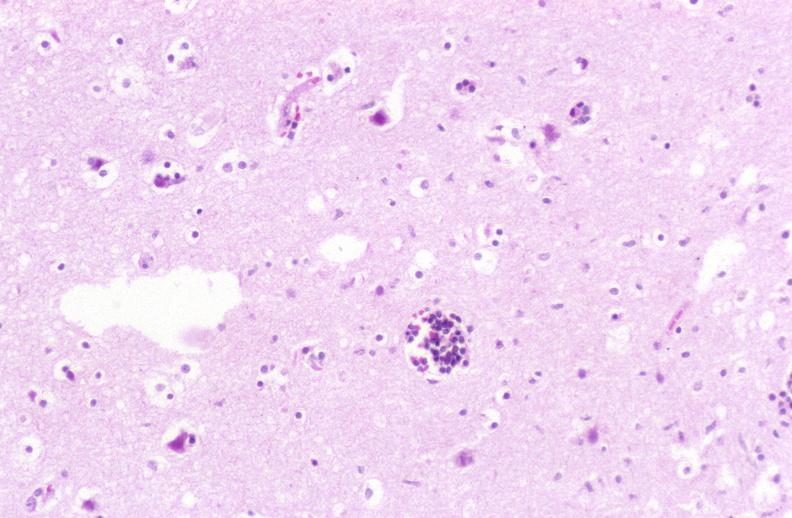does this image show brain, herpes encephalitis, perivascular cuffing?
Answer the question using a single word or phrase. Yes 